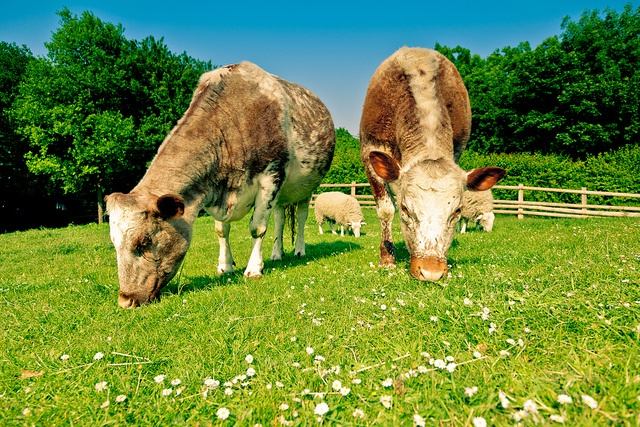Describe the objects in this image and their specific colors. I can see cow in teal, tan, olive, and black tones, cow in teal, tan, brown, and maroon tones, sheep in teal, khaki, tan, and beige tones, and sheep in teal, tan, olive, and beige tones in this image. 